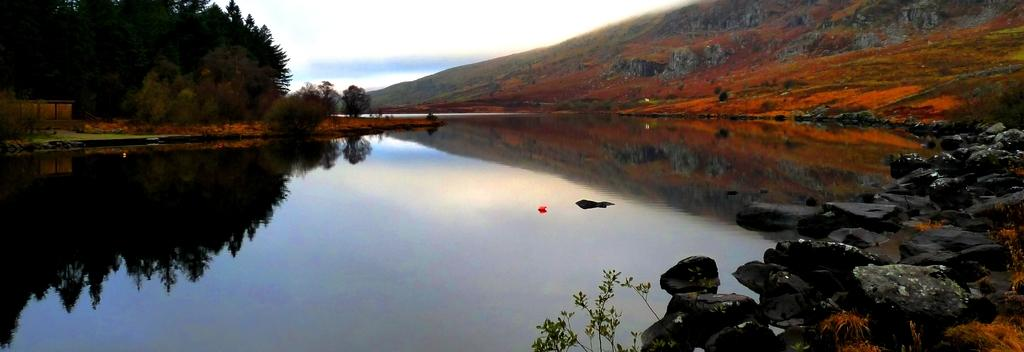What type of natural landscape can be seen in the image? The image contains trees, mountains, and water. What type of terrain is visible in the image? There are stones visible in the image. What part of the natural environment is visible in the image? The sky is visible in the image. What type of joke is being told by the minister in the image? There is no minister or joke present in the image. What type of bag is being used to carry the stones in the image? There is no bag visible in the image; only stones are present. 